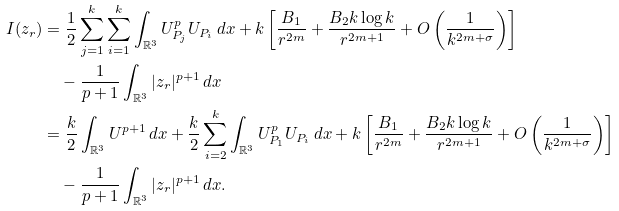<formula> <loc_0><loc_0><loc_500><loc_500>I ( z _ { r } ) & = \frac { 1 } { 2 } \sum _ { j = 1 } ^ { k } \sum _ { i = 1 } ^ { k } \int _ { \mathbb { R } ^ { 3 } } U _ { P _ { j } } ^ { p } U _ { P _ { i } } \, d x + k \left [ \frac { B _ { 1 } } { r ^ { 2 m } } + \frac { B _ { 2 } k \log k } { r ^ { 2 m + 1 } } + O \left ( \frac { 1 } { k ^ { 2 m + \sigma } } \right ) \right ] \\ & \quad - \frac { 1 } { p + 1 } \int _ { \mathbb { R } ^ { 3 } } | z _ { r } | ^ { p + 1 } \, d x \\ & = \frac { k } { 2 } \int _ { \mathbb { R } ^ { 3 } } U ^ { p + 1 } \, d x + \frac { k } { 2 } \sum _ { i = 2 } ^ { k } \int _ { \mathbb { R } ^ { 3 } } U _ { P _ { 1 } } ^ { p } U _ { P _ { i } } \, d x + k \left [ \frac { B _ { 1 } } { r ^ { 2 m } } + \frac { B _ { 2 } k \log k } { r ^ { 2 m + 1 } } + O \left ( \frac { 1 } { k ^ { 2 m + \sigma } } \right ) \right ] \\ & \quad - \frac { 1 } { p + 1 } \int _ { \mathbb { R } ^ { 3 } } | z _ { r } | ^ { p + 1 } \, d x .</formula> 